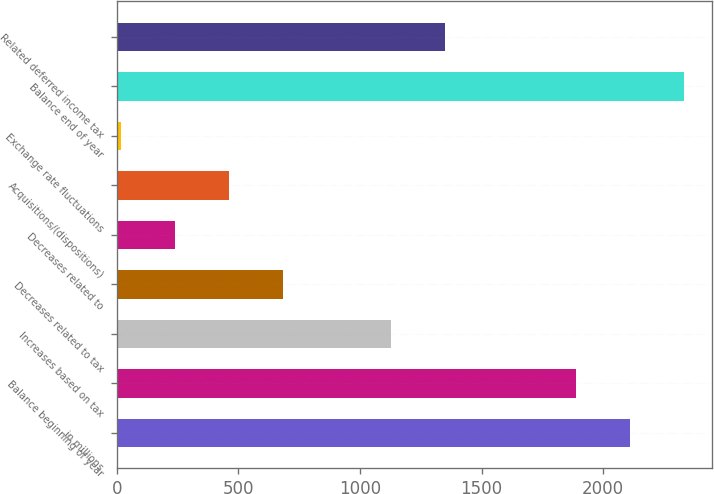Convert chart to OTSL. <chart><loc_0><loc_0><loc_500><loc_500><bar_chart><fcel>in millions<fcel>Balance beginning of year<fcel>Increases based on tax<fcel>Decreases related to tax<fcel>Decreases related to<fcel>Acquisitions/(dispositions)<fcel>Exchange rate fluctuations<fcel>Balance end of year<fcel>Related deferred income tax<nl><fcel>2109.2<fcel>1887<fcel>1126<fcel>681.6<fcel>237.2<fcel>459.4<fcel>15<fcel>2331.4<fcel>1348.2<nl></chart> 